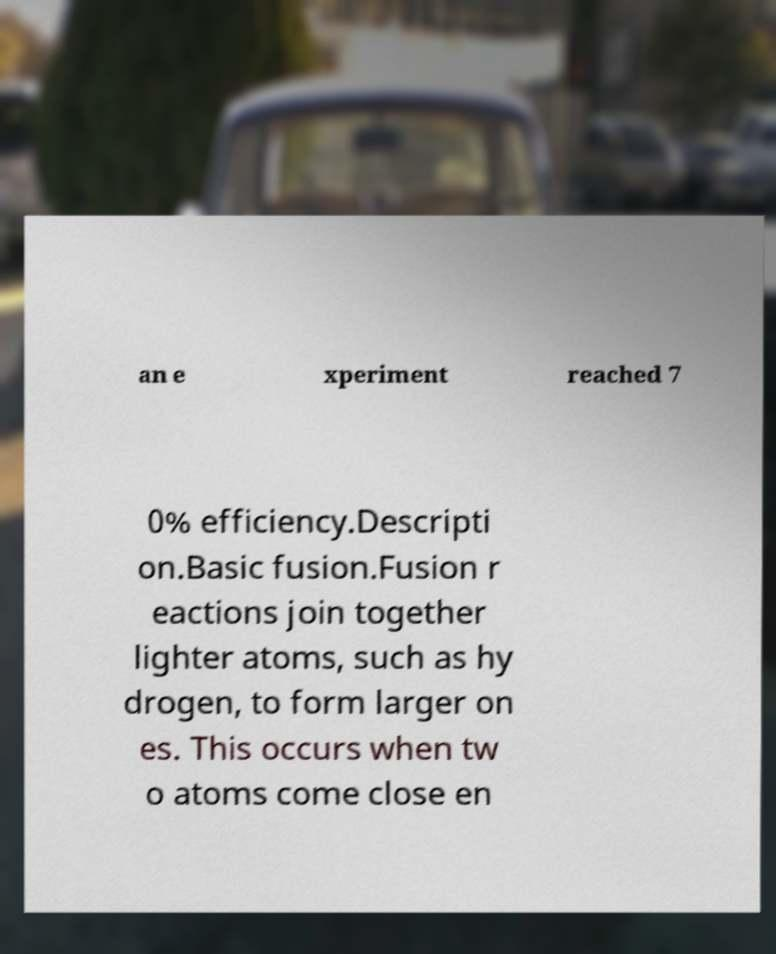Can you read and provide the text displayed in the image?This photo seems to have some interesting text. Can you extract and type it out for me? an e xperiment reached 7 0% efficiency.Descripti on.Basic fusion.Fusion r eactions join together lighter atoms, such as hy drogen, to form larger on es. This occurs when tw o atoms come close en 